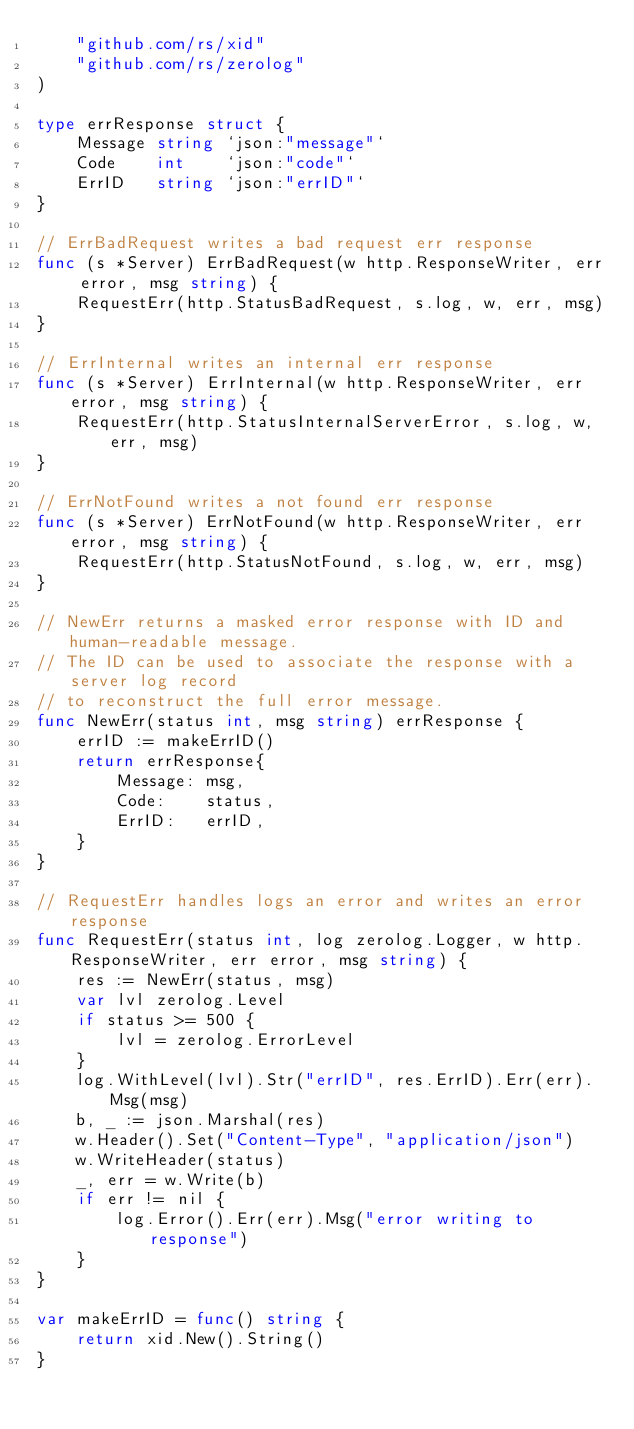<code> <loc_0><loc_0><loc_500><loc_500><_Go_>	"github.com/rs/xid"
	"github.com/rs/zerolog"
)

type errResponse struct {
	Message string `json:"message"`
	Code    int    `json:"code"`
	ErrID   string `json:"errID"`
}

// ErrBadRequest writes a bad request err response
func (s *Server) ErrBadRequest(w http.ResponseWriter, err error, msg string) {
	RequestErr(http.StatusBadRequest, s.log, w, err, msg)
}

// ErrInternal writes an internal err response
func (s *Server) ErrInternal(w http.ResponseWriter, err error, msg string) {
	RequestErr(http.StatusInternalServerError, s.log, w, err, msg)
}

// ErrNotFound writes a not found err response
func (s *Server) ErrNotFound(w http.ResponseWriter, err error, msg string) {
	RequestErr(http.StatusNotFound, s.log, w, err, msg)
}

// NewErr returns a masked error response with ID and human-readable message.
// The ID can be used to associate the response with a server log record
// to reconstruct the full error message.
func NewErr(status int, msg string) errResponse {
	errID := makeErrID()
	return errResponse{
		Message: msg,
		Code:    status,
		ErrID:   errID,
	}
}

// RequestErr handles logs an error and writes an error response
func RequestErr(status int, log zerolog.Logger, w http.ResponseWriter, err error, msg string) {
	res := NewErr(status, msg)
	var lvl zerolog.Level
	if status >= 500 {
		lvl = zerolog.ErrorLevel
	}
	log.WithLevel(lvl).Str("errID", res.ErrID).Err(err).Msg(msg)
	b, _ := json.Marshal(res)
	w.Header().Set("Content-Type", "application/json")
	w.WriteHeader(status)
	_, err = w.Write(b)
	if err != nil {
		log.Error().Err(err).Msg("error writing to response")
	}
}

var makeErrID = func() string {
	return xid.New().String()
}
</code> 